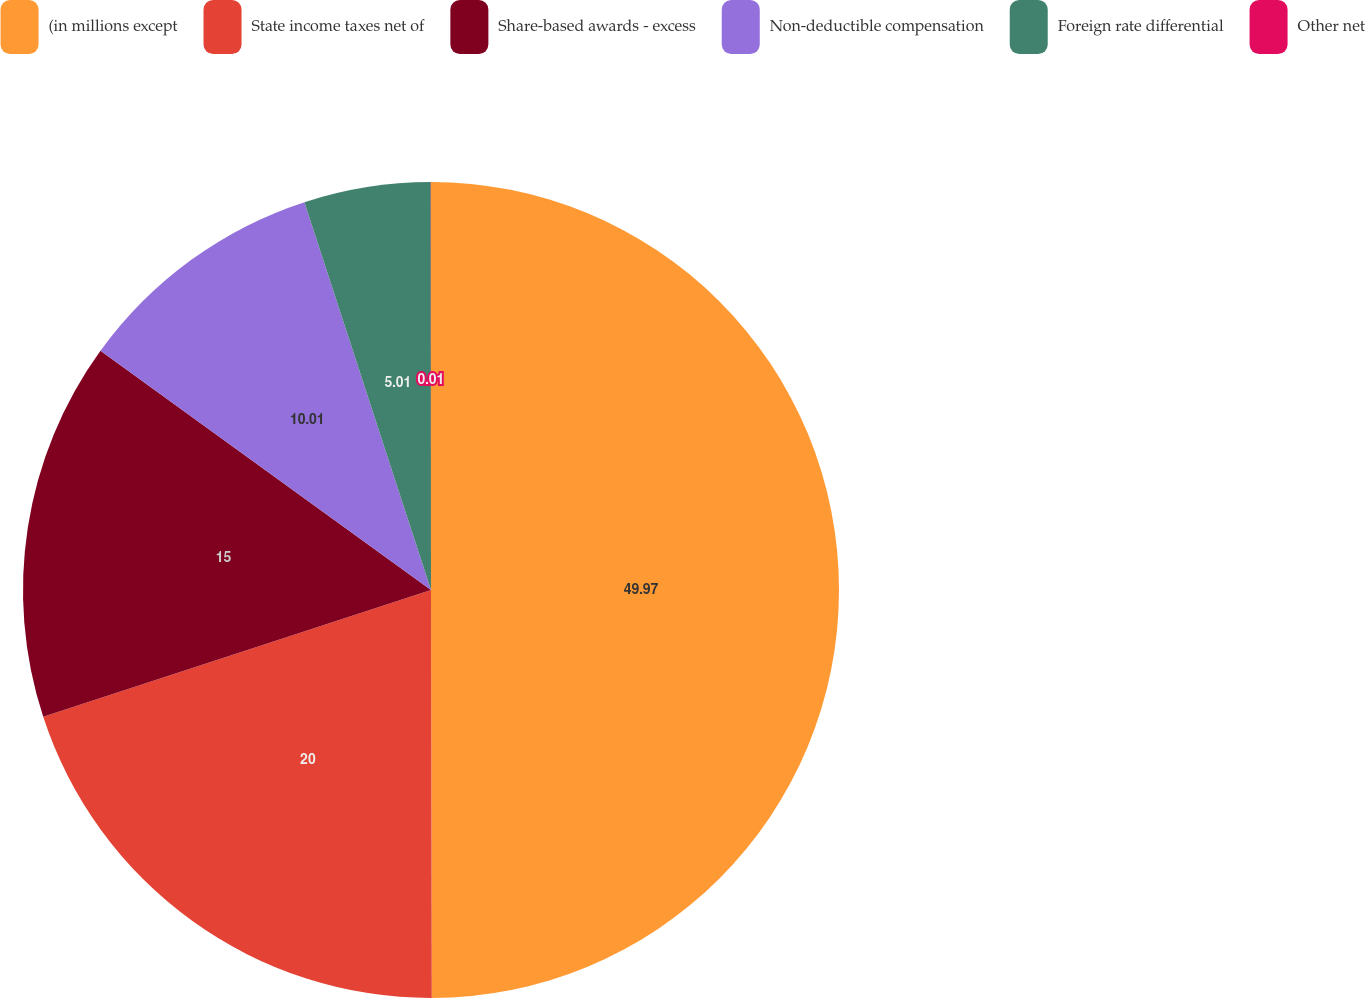Convert chart to OTSL. <chart><loc_0><loc_0><loc_500><loc_500><pie_chart><fcel>(in millions except<fcel>State income taxes net of<fcel>Share-based awards - excess<fcel>Non-deductible compensation<fcel>Foreign rate differential<fcel>Other net<nl><fcel>49.97%<fcel>20.0%<fcel>15.0%<fcel>10.01%<fcel>5.01%<fcel>0.01%<nl></chart> 